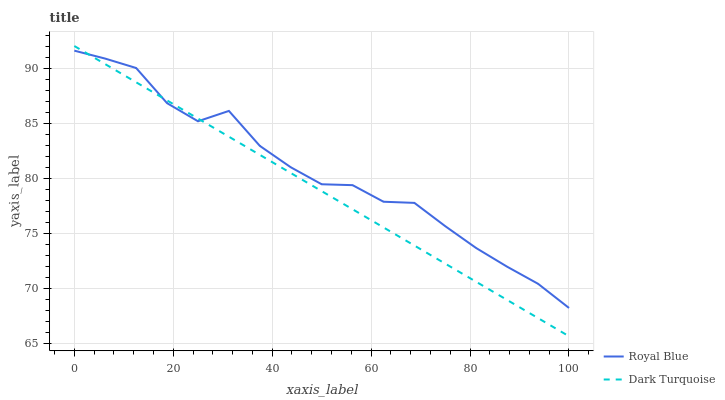Does Dark Turquoise have the minimum area under the curve?
Answer yes or no. Yes. Does Royal Blue have the maximum area under the curve?
Answer yes or no. Yes. Does Dark Turquoise have the maximum area under the curve?
Answer yes or no. No. Is Dark Turquoise the smoothest?
Answer yes or no. Yes. Is Royal Blue the roughest?
Answer yes or no. Yes. Is Dark Turquoise the roughest?
Answer yes or no. No. Does Dark Turquoise have the highest value?
Answer yes or no. Yes. Does Royal Blue intersect Dark Turquoise?
Answer yes or no. Yes. Is Royal Blue less than Dark Turquoise?
Answer yes or no. No. Is Royal Blue greater than Dark Turquoise?
Answer yes or no. No. 